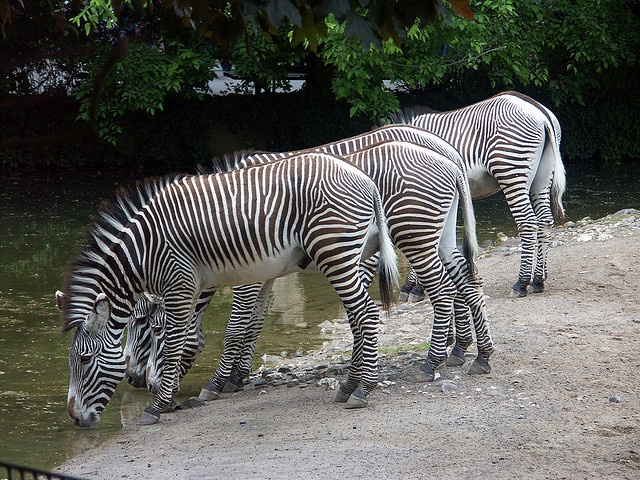Describe the objects in this image and their specific colors. I can see zebra in black, gray, darkgray, and lightgray tones, zebra in black, lightgray, gray, and darkgray tones, zebra in black, white, gray, and darkgray tones, and zebra in black, white, gray, and darkgray tones in this image. 